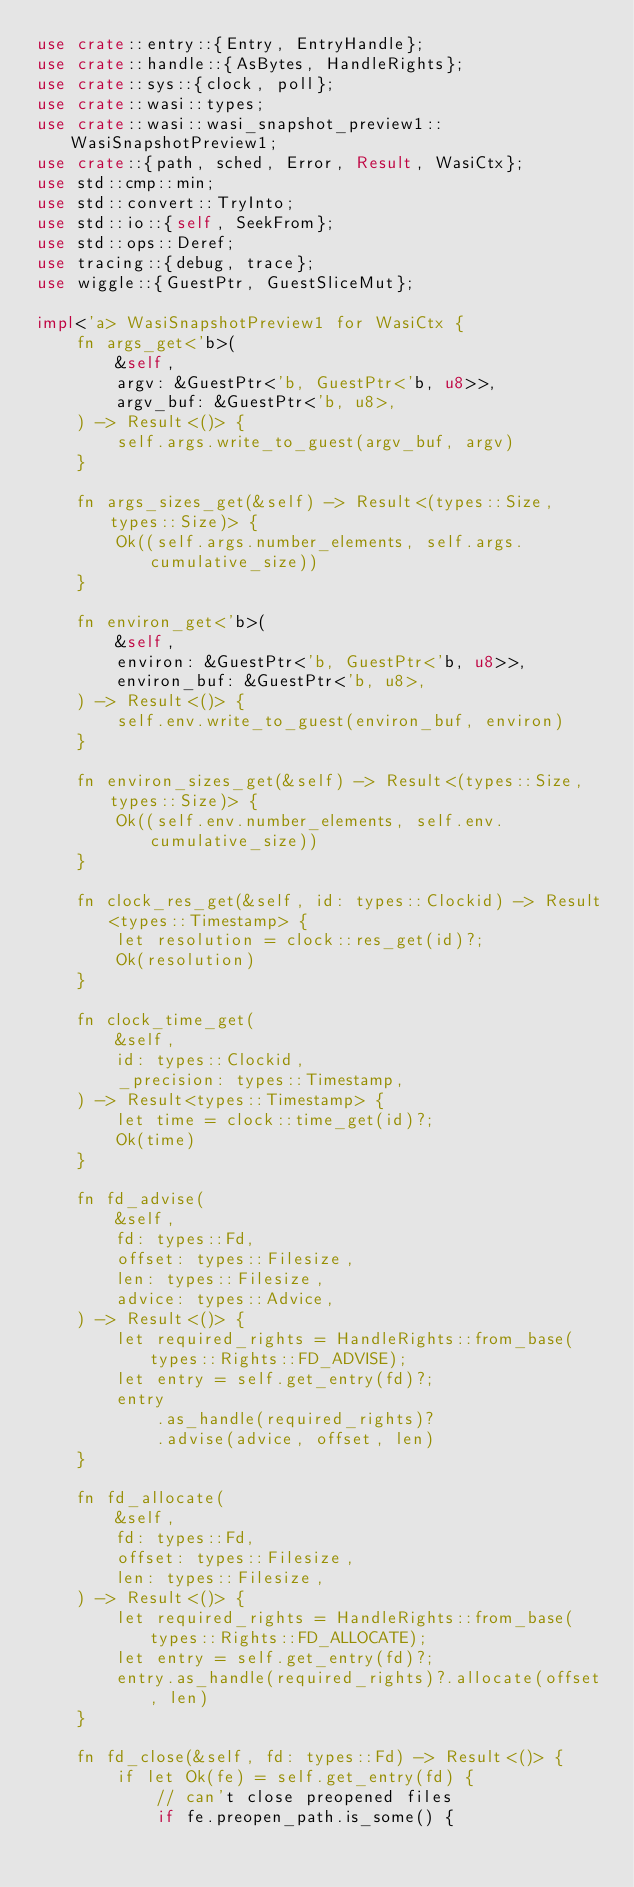Convert code to text. <code><loc_0><loc_0><loc_500><loc_500><_Rust_>use crate::entry::{Entry, EntryHandle};
use crate::handle::{AsBytes, HandleRights};
use crate::sys::{clock, poll};
use crate::wasi::types;
use crate::wasi::wasi_snapshot_preview1::WasiSnapshotPreview1;
use crate::{path, sched, Error, Result, WasiCtx};
use std::cmp::min;
use std::convert::TryInto;
use std::io::{self, SeekFrom};
use std::ops::Deref;
use tracing::{debug, trace};
use wiggle::{GuestPtr, GuestSliceMut};

impl<'a> WasiSnapshotPreview1 for WasiCtx {
    fn args_get<'b>(
        &self,
        argv: &GuestPtr<'b, GuestPtr<'b, u8>>,
        argv_buf: &GuestPtr<'b, u8>,
    ) -> Result<()> {
        self.args.write_to_guest(argv_buf, argv)
    }

    fn args_sizes_get(&self) -> Result<(types::Size, types::Size)> {
        Ok((self.args.number_elements, self.args.cumulative_size))
    }

    fn environ_get<'b>(
        &self,
        environ: &GuestPtr<'b, GuestPtr<'b, u8>>,
        environ_buf: &GuestPtr<'b, u8>,
    ) -> Result<()> {
        self.env.write_to_guest(environ_buf, environ)
    }

    fn environ_sizes_get(&self) -> Result<(types::Size, types::Size)> {
        Ok((self.env.number_elements, self.env.cumulative_size))
    }

    fn clock_res_get(&self, id: types::Clockid) -> Result<types::Timestamp> {
        let resolution = clock::res_get(id)?;
        Ok(resolution)
    }

    fn clock_time_get(
        &self,
        id: types::Clockid,
        _precision: types::Timestamp,
    ) -> Result<types::Timestamp> {
        let time = clock::time_get(id)?;
        Ok(time)
    }

    fn fd_advise(
        &self,
        fd: types::Fd,
        offset: types::Filesize,
        len: types::Filesize,
        advice: types::Advice,
    ) -> Result<()> {
        let required_rights = HandleRights::from_base(types::Rights::FD_ADVISE);
        let entry = self.get_entry(fd)?;
        entry
            .as_handle(required_rights)?
            .advise(advice, offset, len)
    }

    fn fd_allocate(
        &self,
        fd: types::Fd,
        offset: types::Filesize,
        len: types::Filesize,
    ) -> Result<()> {
        let required_rights = HandleRights::from_base(types::Rights::FD_ALLOCATE);
        let entry = self.get_entry(fd)?;
        entry.as_handle(required_rights)?.allocate(offset, len)
    }

    fn fd_close(&self, fd: types::Fd) -> Result<()> {
        if let Ok(fe) = self.get_entry(fd) {
            // can't close preopened files
            if fe.preopen_path.is_some() {</code> 